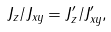Convert formula to latex. <formula><loc_0><loc_0><loc_500><loc_500>J _ { z } / J _ { x y } = J ^ { \prime } _ { z } / J ^ { \prime } _ { x y } \/ ,</formula> 